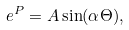Convert formula to latex. <formula><loc_0><loc_0><loc_500><loc_500>e ^ { P } = A \sin ( \alpha \Theta ) ,</formula> 